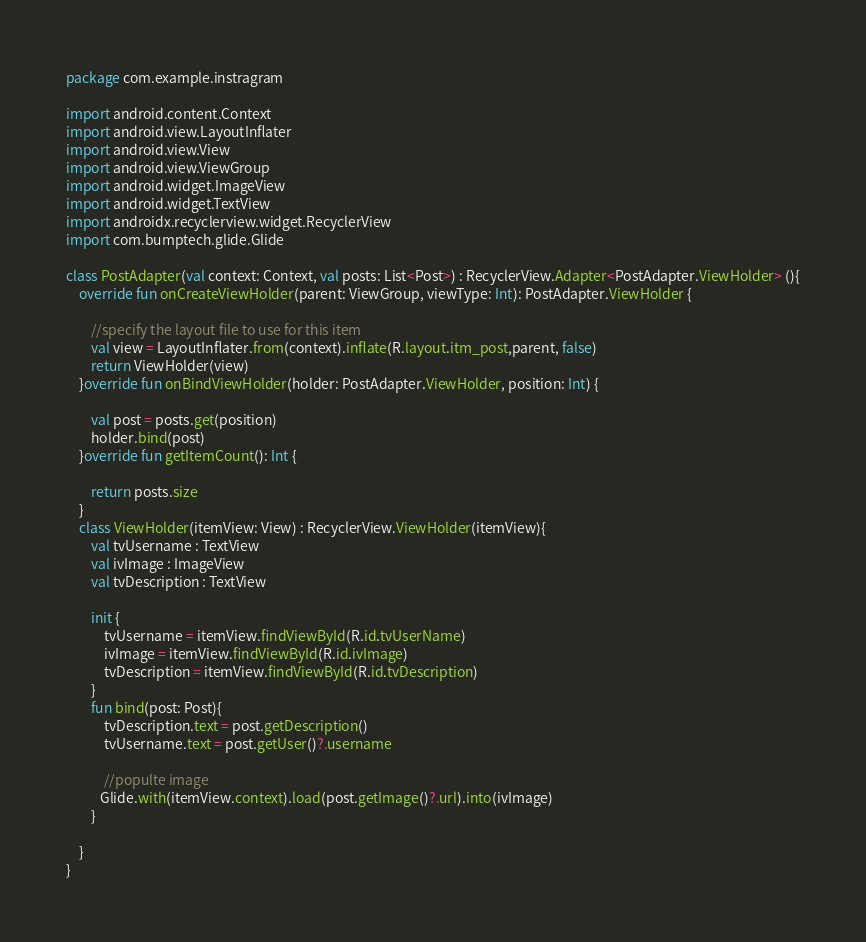Convert code to text. <code><loc_0><loc_0><loc_500><loc_500><_Kotlin_>package com.example.instragram

import android.content.Context
import android.view.LayoutInflater
import android.view.View
import android.view.ViewGroup
import android.widget.ImageView
import android.widget.TextView
import androidx.recyclerview.widget.RecyclerView
import com.bumptech.glide.Glide

class PostAdapter(val context: Context, val posts: List<Post>) : RecyclerView.Adapter<PostAdapter.ViewHolder> (){
    override fun onCreateViewHolder(parent: ViewGroup, viewType: Int): PostAdapter.ViewHolder {

        //specify the layout file to use for this item
        val view = LayoutInflater.from(context).inflate(R.layout.itm_post,parent, false)
        return ViewHolder(view)
    }override fun onBindViewHolder(holder: PostAdapter.ViewHolder, position: Int) {

        val post = posts.get(position)
        holder.bind(post)
    }override fun getItemCount(): Int {

        return posts.size
    }
    class ViewHolder(itemView: View) : RecyclerView.ViewHolder(itemView){
        val tvUsername : TextView
        val ivImage : ImageView
        val tvDescription : TextView

        init {
            tvUsername = itemView.findViewById(R.id.tvUserName)
            ivImage = itemView.findViewById(R.id.ivImage)
            tvDescription = itemView.findViewById(R.id.tvDescription)
        }
        fun bind(post: Post){
            tvDescription.text = post.getDescription()
            tvUsername.text = post.getUser()?.username

            //populte image
           Glide.with(itemView.context).load(post.getImage()?.url).into(ivImage)
        }

    }
}</code> 